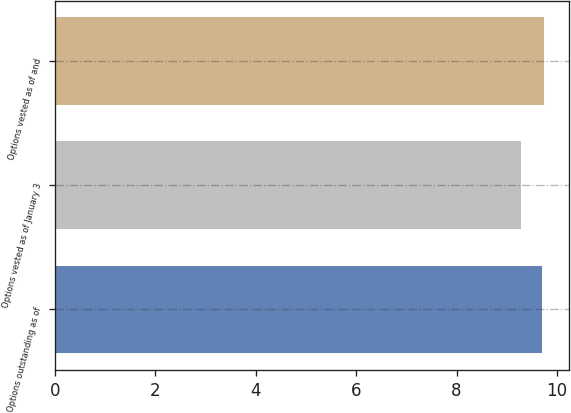Convert chart. <chart><loc_0><loc_0><loc_500><loc_500><bar_chart><fcel>Options outstanding as of<fcel>Options vested as of January 3<fcel>Options vested as of and<nl><fcel>9.71<fcel>9.28<fcel>9.75<nl></chart> 